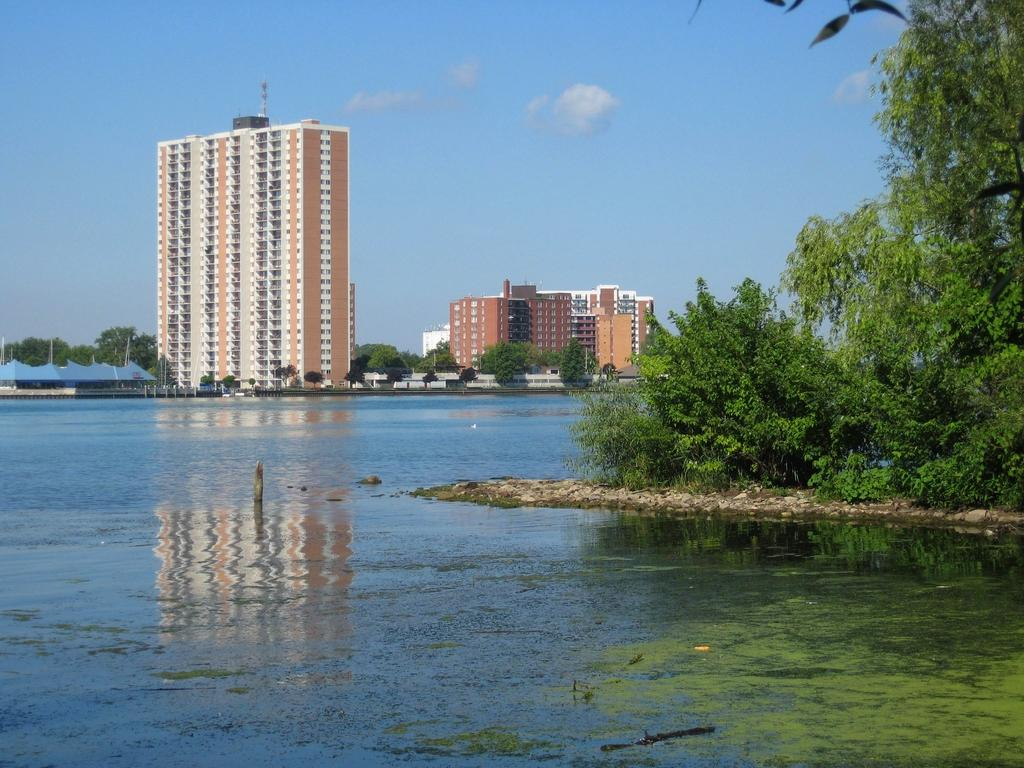What is the main feature of the image? There is water with algae in the image. What can be seen on the right side of the image? There are plants and trees on the right side of the image, as well as a stone. What is visible in the background of the image? There are buildings, trees, plants, and blue sheds in the background of the image, along with the sky. What type of flowers are growing in the tub in the image? There is no tub or flowers present in the image. 